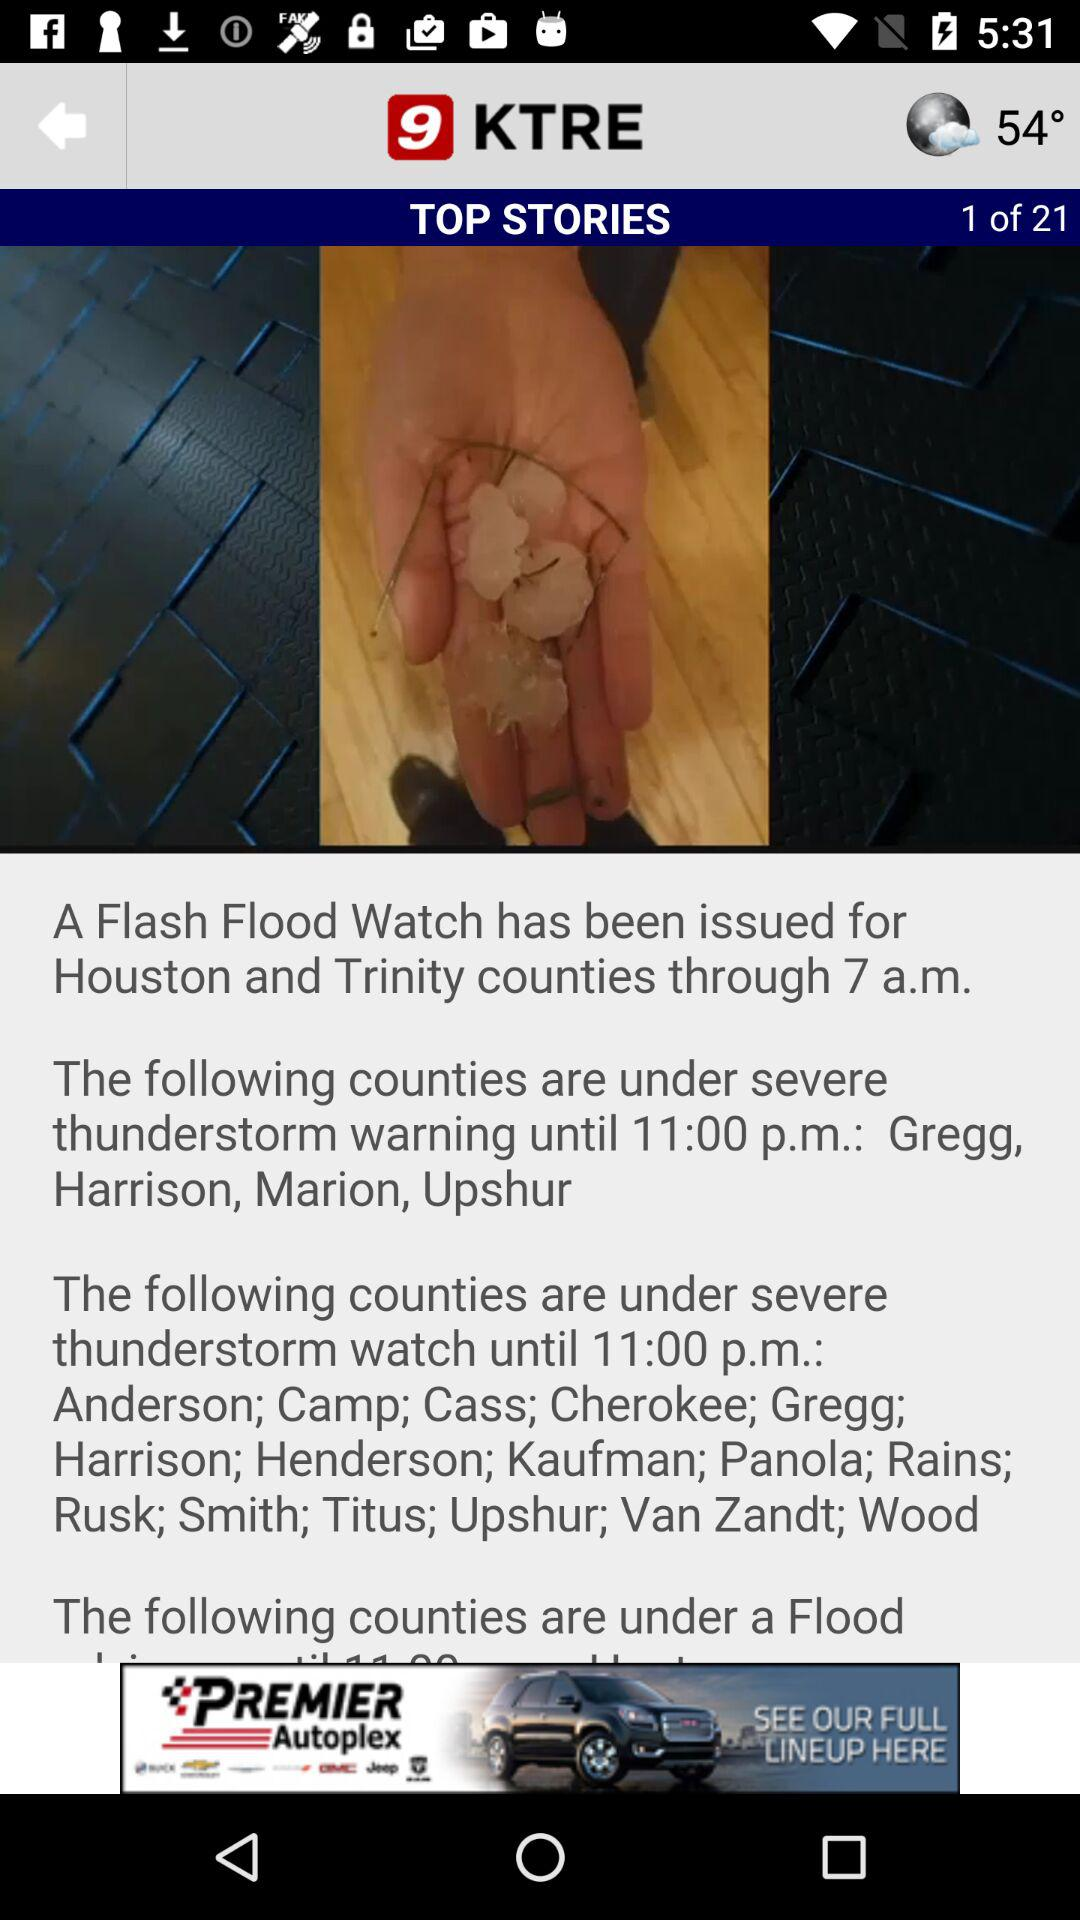At which story am I? You are at the first story. 